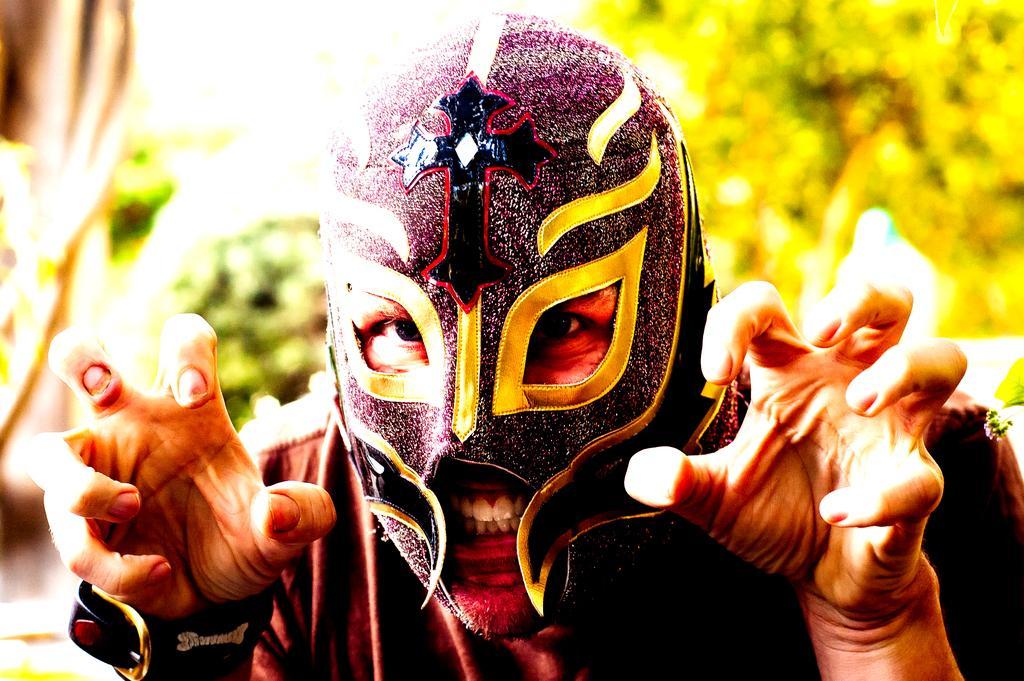In one or two sentences, can you explain what this image depicts? in the given picture i can see a person wearing a mask and behind a person i can see a tree. 